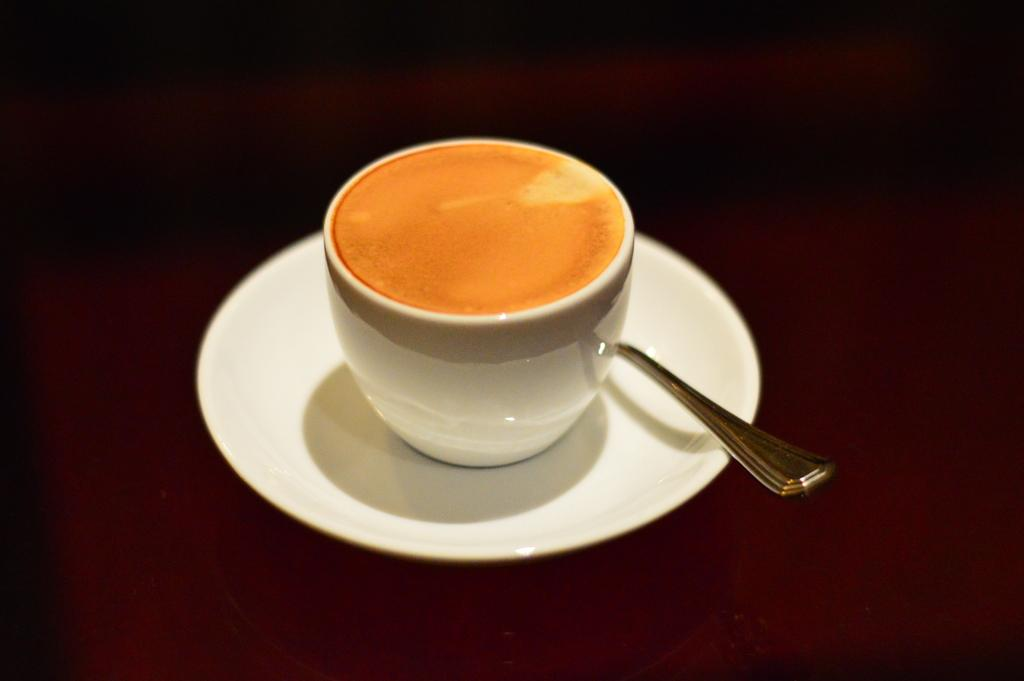What is present on the table in the image? There is a cup and a saucer on the table in the image. What is inside the cup? There is tea in the cup. What is placed on the saucer? There is a spoon in the saucer. How many geese are flying over the cup and saucer in the image? There are no geese present in the image; it only features a cup, saucer, tea, and spoon. 